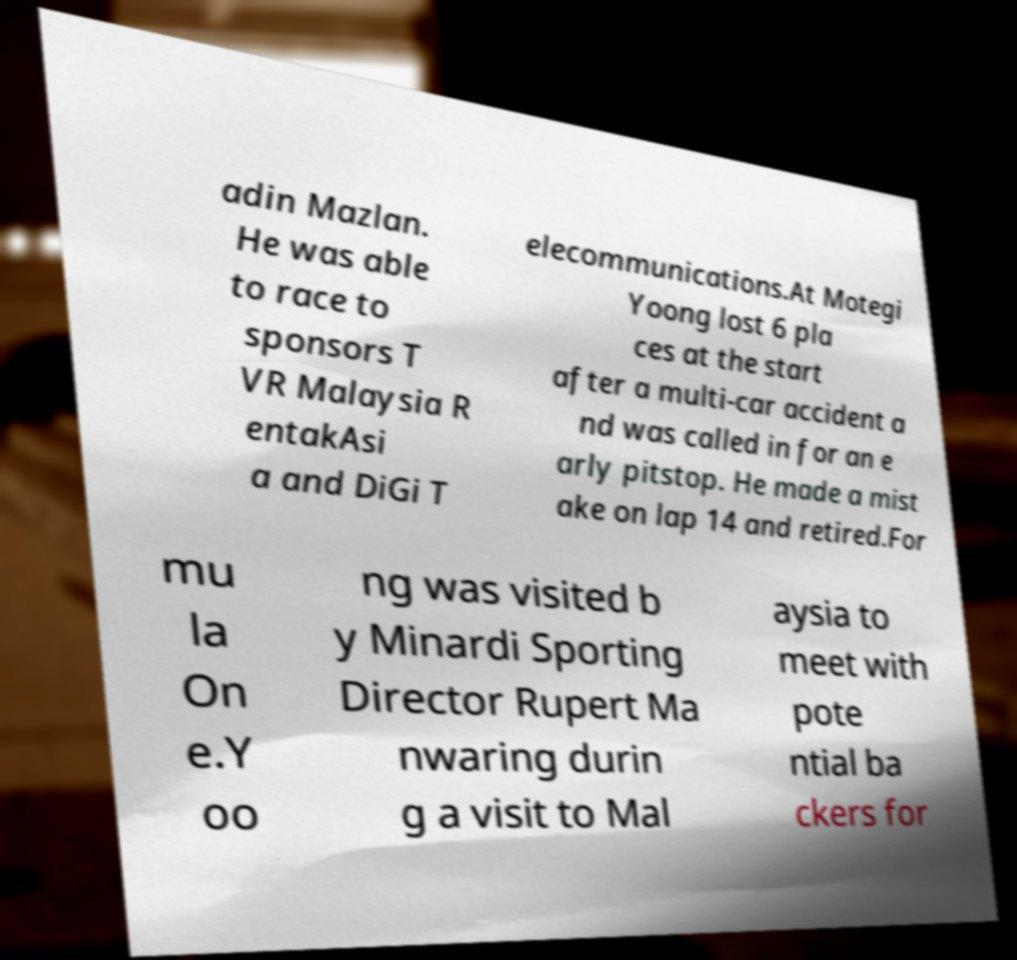Please identify and transcribe the text found in this image. adin Mazlan. He was able to race to sponsors T VR Malaysia R entakAsi a and DiGi T elecommunications.At Motegi Yoong lost 6 pla ces at the start after a multi-car accident a nd was called in for an e arly pitstop. He made a mist ake on lap 14 and retired.For mu la On e.Y oo ng was visited b y Minardi Sporting Director Rupert Ma nwaring durin g a visit to Mal aysia to meet with pote ntial ba ckers for 